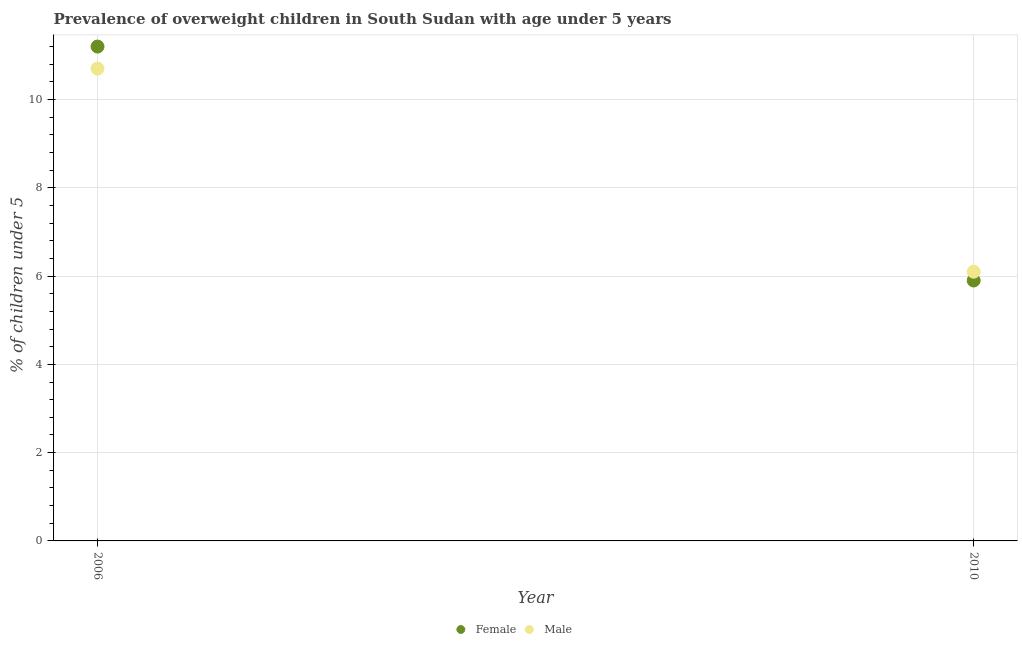How many different coloured dotlines are there?
Your answer should be compact. 2. What is the percentage of obese male children in 2006?
Give a very brief answer. 10.7. Across all years, what is the maximum percentage of obese female children?
Provide a succinct answer. 11.2. Across all years, what is the minimum percentage of obese male children?
Give a very brief answer. 6.1. In which year was the percentage of obese female children minimum?
Keep it short and to the point. 2010. What is the total percentage of obese male children in the graph?
Provide a succinct answer. 16.8. What is the difference between the percentage of obese female children in 2006 and that in 2010?
Provide a short and direct response. 5.3. What is the difference between the percentage of obese male children in 2010 and the percentage of obese female children in 2006?
Offer a very short reply. -5.1. What is the average percentage of obese female children per year?
Provide a succinct answer. 8.55. In the year 2006, what is the difference between the percentage of obese female children and percentage of obese male children?
Provide a succinct answer. 0.5. What is the ratio of the percentage of obese female children in 2006 to that in 2010?
Offer a very short reply. 1.9. Is the percentage of obese male children in 2006 less than that in 2010?
Make the answer very short. No. Is the percentage of obese male children strictly greater than the percentage of obese female children over the years?
Your response must be concise. No. What is the difference between two consecutive major ticks on the Y-axis?
Your response must be concise. 2. Are the values on the major ticks of Y-axis written in scientific E-notation?
Ensure brevity in your answer.  No. Does the graph contain any zero values?
Make the answer very short. No. Does the graph contain grids?
Provide a short and direct response. Yes. Where does the legend appear in the graph?
Offer a very short reply. Bottom center. How many legend labels are there?
Offer a terse response. 2. What is the title of the graph?
Ensure brevity in your answer.  Prevalence of overweight children in South Sudan with age under 5 years. What is the label or title of the X-axis?
Ensure brevity in your answer.  Year. What is the label or title of the Y-axis?
Provide a short and direct response.  % of children under 5. What is the  % of children under 5 of Female in 2006?
Keep it short and to the point. 11.2. What is the  % of children under 5 of Male in 2006?
Make the answer very short. 10.7. What is the  % of children under 5 of Female in 2010?
Provide a short and direct response. 5.9. What is the  % of children under 5 in Male in 2010?
Ensure brevity in your answer.  6.1. Across all years, what is the maximum  % of children under 5 in Female?
Offer a very short reply. 11.2. Across all years, what is the maximum  % of children under 5 of Male?
Your answer should be compact. 10.7. Across all years, what is the minimum  % of children under 5 in Female?
Provide a succinct answer. 5.9. Across all years, what is the minimum  % of children under 5 of Male?
Provide a short and direct response. 6.1. What is the total  % of children under 5 in Female in the graph?
Provide a succinct answer. 17.1. What is the average  % of children under 5 in Female per year?
Your response must be concise. 8.55. What is the average  % of children under 5 in Male per year?
Provide a short and direct response. 8.4. In the year 2006, what is the difference between the  % of children under 5 of Female and  % of children under 5 of Male?
Keep it short and to the point. 0.5. What is the ratio of the  % of children under 5 of Female in 2006 to that in 2010?
Provide a succinct answer. 1.9. What is the ratio of the  % of children under 5 in Male in 2006 to that in 2010?
Offer a very short reply. 1.75. What is the difference between the highest and the second highest  % of children under 5 in Female?
Ensure brevity in your answer.  5.3. What is the difference between the highest and the second highest  % of children under 5 of Male?
Give a very brief answer. 4.6. What is the difference between the highest and the lowest  % of children under 5 in Male?
Provide a succinct answer. 4.6. 